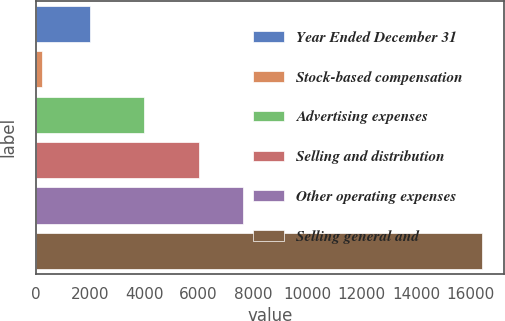<chart> <loc_0><loc_0><loc_500><loc_500><bar_chart><fcel>Year Ended December 31<fcel>Stock-based compensation<fcel>Advertising expenses<fcel>Selling and distribution<fcel>Other operating expenses<fcel>Selling general and<nl><fcel>2015<fcel>236<fcel>3976<fcel>6025<fcel>7644.1<fcel>16427<nl></chart> 